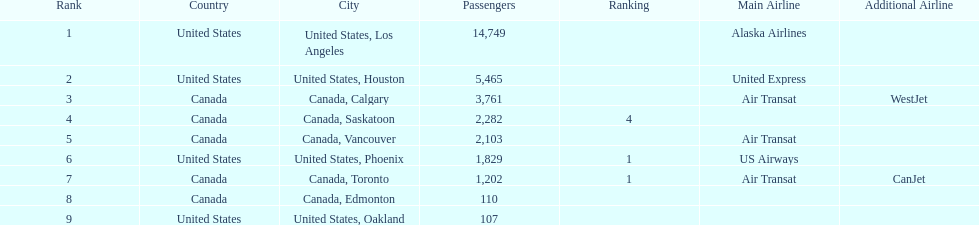Was los angeles or houston the busiest international route at manzanillo international airport in 2013? Los Angeles. Would you mind parsing the complete table? {'header': ['Rank', 'Country', 'City', 'Passengers', 'Ranking', 'Main Airline', 'Additional Airline'], 'rows': [['1', 'United States', 'United States, Los Angeles', '14,749', '', 'Alaska Airlines', ''], ['2', 'United States', 'United States, Houston', '5,465', '', 'United Express', ''], ['3', 'Canada', 'Canada, Calgary', '3,761', '', 'Air Transat', 'WestJet'], ['4', 'Canada', 'Canada, Saskatoon', '2,282', '4', '', ''], ['5', 'Canada', 'Canada, Vancouver', '2,103', '', 'Air Transat', ''], ['6', 'United States', 'United States, Phoenix', '1,829', '1', 'US Airways', ''], ['7', 'Canada', 'Canada, Toronto', '1,202', '1', 'Air Transat', 'CanJet'], ['8', 'Canada', 'Canada, Edmonton', '110', '', '', ''], ['9', 'United States', 'United States, Oakland', '107', '', '', '']]} 